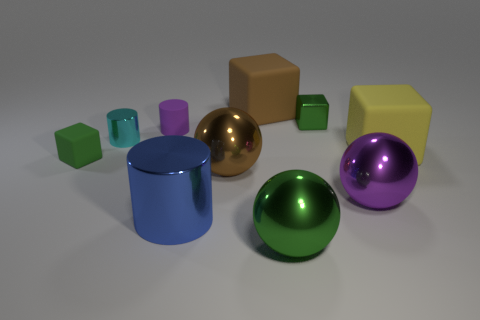Subtract all small purple rubber cylinders. How many cylinders are left? 2 How many green cubes must be subtracted to get 1 green cubes? 1 Subtract all cubes. How many objects are left? 6 Subtract all red cylinders. Subtract all brown balls. How many cylinders are left? 3 Subtract all gray spheres. How many purple cylinders are left? 1 Subtract all big blue metal cylinders. Subtract all purple shiny things. How many objects are left? 8 Add 5 tiny objects. How many tiny objects are left? 9 Add 1 metal things. How many metal things exist? 7 Subtract all blue cylinders. How many cylinders are left? 2 Subtract 0 blue blocks. How many objects are left? 10 